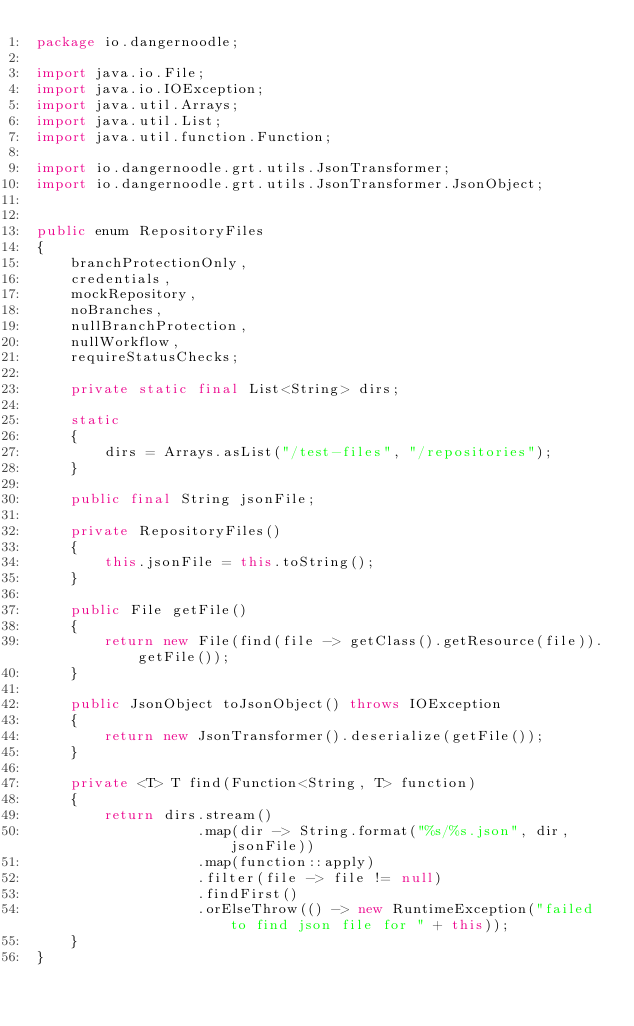Convert code to text. <code><loc_0><loc_0><loc_500><loc_500><_Java_>package io.dangernoodle;

import java.io.File;
import java.io.IOException;
import java.util.Arrays;
import java.util.List;
import java.util.function.Function;

import io.dangernoodle.grt.utils.JsonTransformer;
import io.dangernoodle.grt.utils.JsonTransformer.JsonObject;


public enum RepositoryFiles
{
    branchProtectionOnly,
    credentials,
    mockRepository,
    noBranches,
    nullBranchProtection,
    nullWorkflow,
    requireStatusChecks;

    private static final List<String> dirs;

    static
    {
        dirs = Arrays.asList("/test-files", "/repositories");
    }

    public final String jsonFile;

    private RepositoryFiles()
    {
        this.jsonFile = this.toString();
    }

    public File getFile()
    {
        return new File(find(file -> getClass().getResource(file)).getFile());
    }

    public JsonObject toJsonObject() throws IOException
    {
        return new JsonTransformer().deserialize(getFile());
    }

    private <T> T find(Function<String, T> function)
    {
        return dirs.stream()
                   .map(dir -> String.format("%s/%s.json", dir, jsonFile))
                   .map(function::apply)
                   .filter(file -> file != null)
                   .findFirst()
                   .orElseThrow(() -> new RuntimeException("failed to find json file for " + this));
    }
}
</code> 